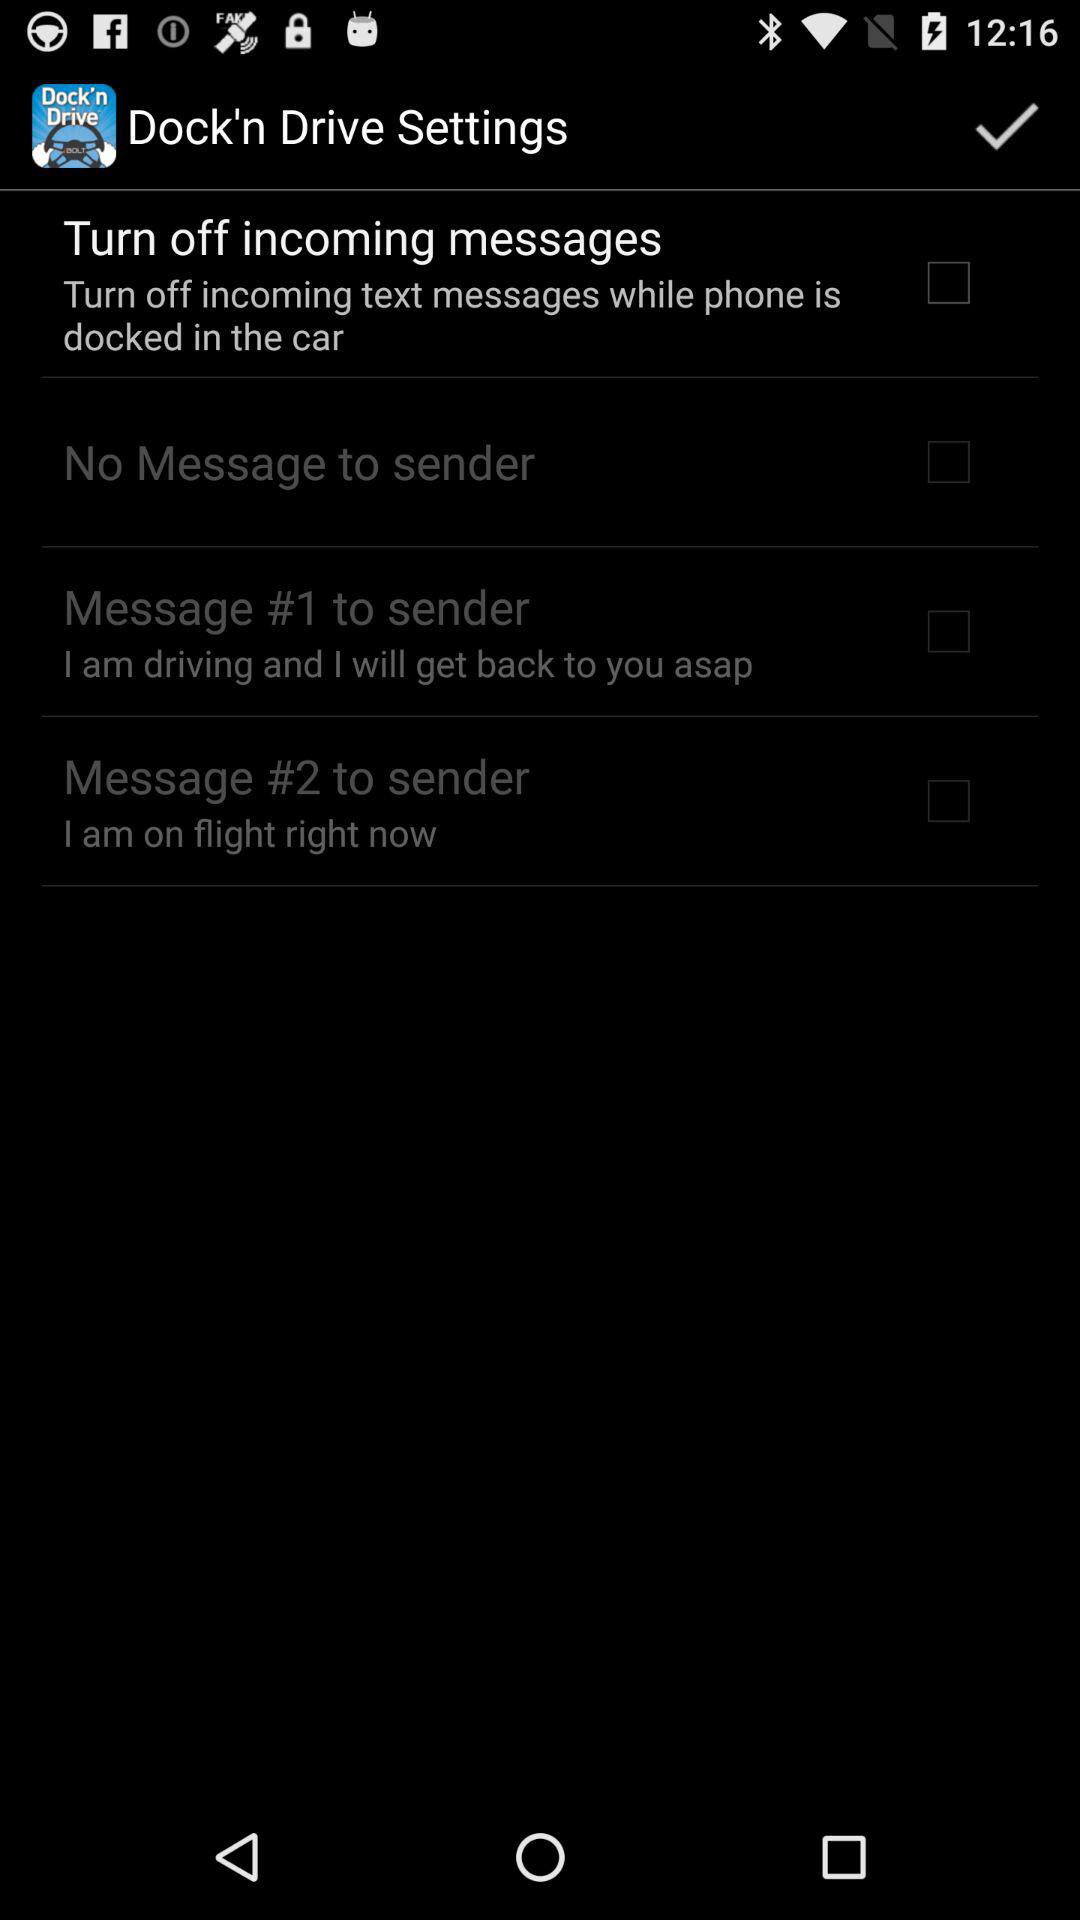What is the setting for "Message #1 to sender"? The setting for "Message #1 to sender" is "I am driving and I will get back to you asap". 